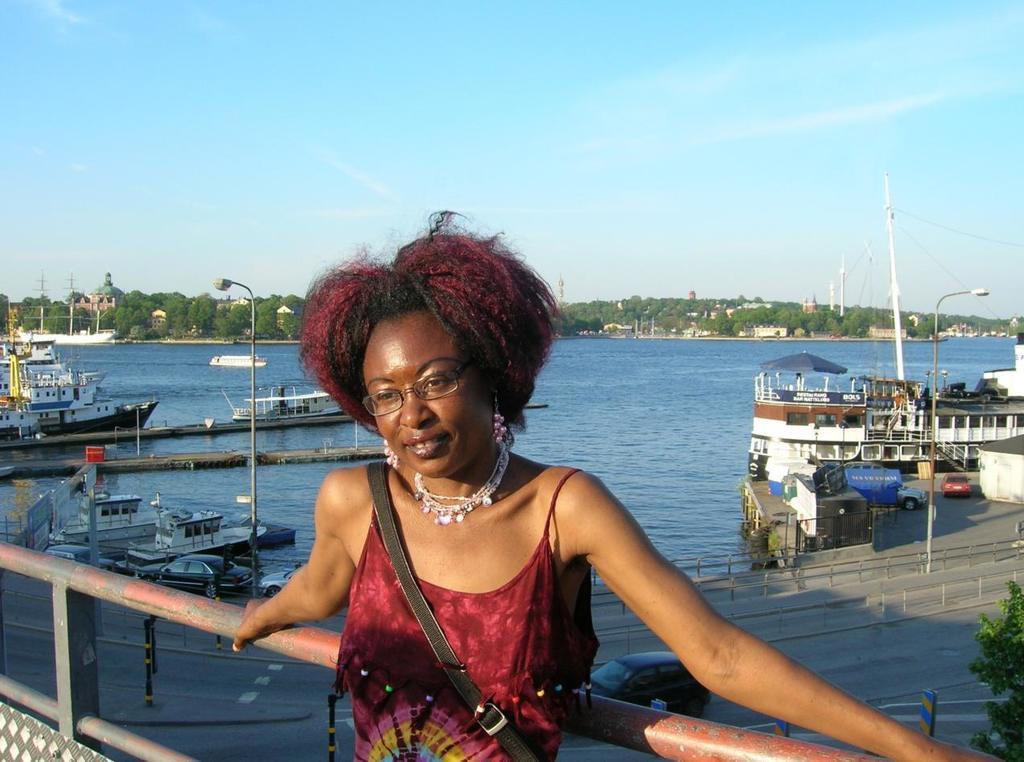Describe this image in one or two sentences. In the image there is a woman in maroon vest standing in front of fence and in the back there is sea with ships in it,in the background there are buildings and trees and above its sky. 